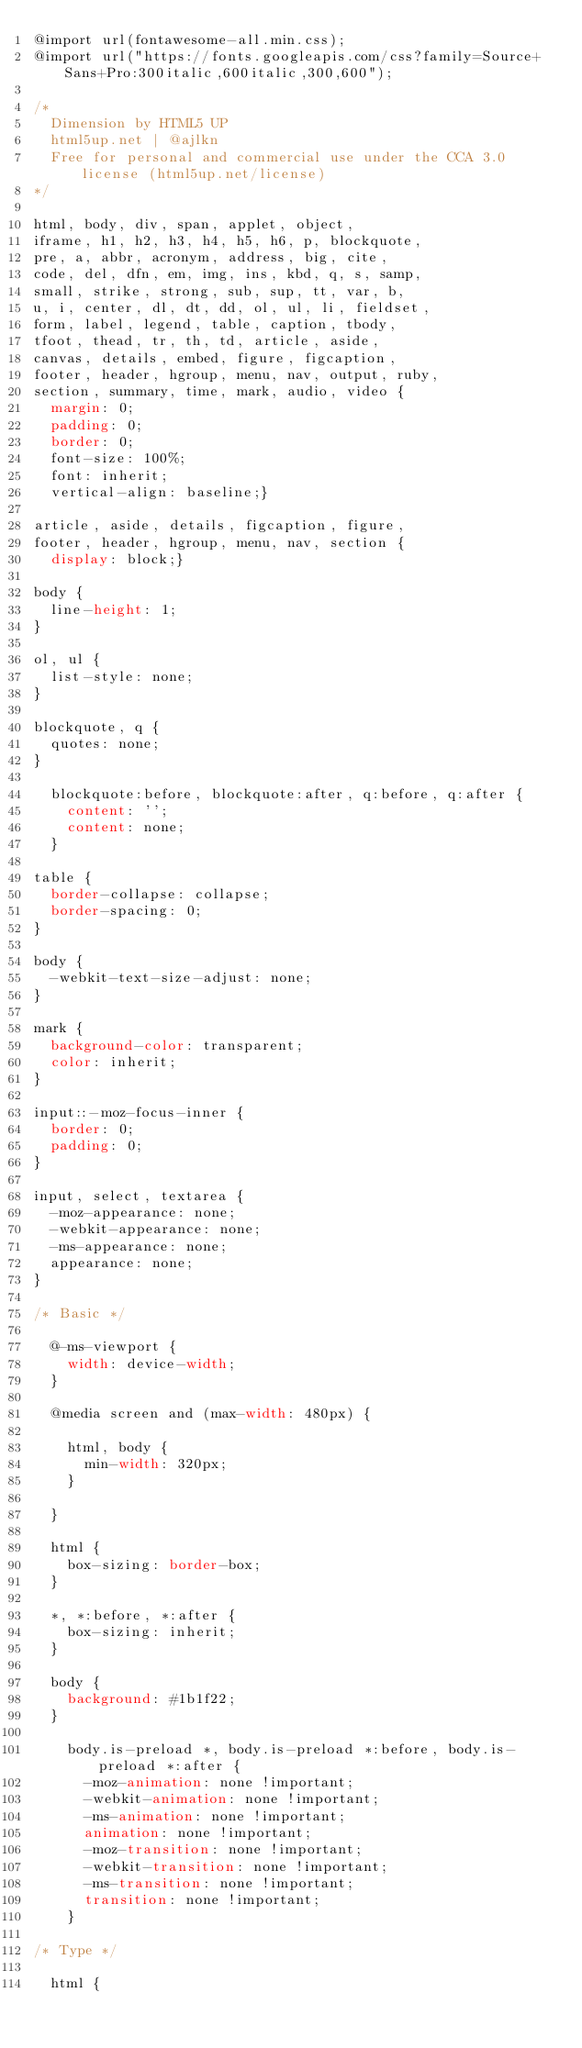Convert code to text. <code><loc_0><loc_0><loc_500><loc_500><_CSS_>@import url(fontawesome-all.min.css);
@import url("https://fonts.googleapis.com/css?family=Source+Sans+Pro:300italic,600italic,300,600");

/*
	Dimension by HTML5 UP
	html5up.net | @ajlkn
	Free for personal and commercial use under the CCA 3.0 license (html5up.net/license)
*/

html, body, div, span, applet, object,
iframe, h1, h2, h3, h4, h5, h6, p, blockquote,
pre, a, abbr, acronym, address, big, cite,
code, del, dfn, em, img, ins, kbd, q, s, samp,
small, strike, strong, sub, sup, tt, var, b,
u, i, center, dl, dt, dd, ol, ul, li, fieldset,
form, label, legend, table, caption, tbody,
tfoot, thead, tr, th, td, article, aside,
canvas, details, embed, figure, figcaption,
footer, header, hgroup, menu, nav, output, ruby,
section, summary, time, mark, audio, video {
	margin: 0;
	padding: 0;
	border: 0;
	font-size: 100%;
	font: inherit;
	vertical-align: baseline;}

article, aside, details, figcaption, figure,
footer, header, hgroup, menu, nav, section {
	display: block;}

body {
	line-height: 1;
}

ol, ul {
	list-style: none;
}

blockquote, q {
	quotes: none;
}

	blockquote:before, blockquote:after, q:before, q:after {
		content: '';
		content: none;
	}

table {
	border-collapse: collapse;
	border-spacing: 0;
}

body {
	-webkit-text-size-adjust: none;
}

mark {
	background-color: transparent;
	color: inherit;
}

input::-moz-focus-inner {
	border: 0;
	padding: 0;
}

input, select, textarea {
	-moz-appearance: none;
	-webkit-appearance: none;
	-ms-appearance: none;
	appearance: none;
}

/* Basic */

	@-ms-viewport {
		width: device-width;
	}

	@media screen and (max-width: 480px) {

		html, body {
			min-width: 320px;
		}

	}

	html {
		box-sizing: border-box;
	}

	*, *:before, *:after {
		box-sizing: inherit;
	}

	body {
		background: #1b1f22;
	}

		body.is-preload *, body.is-preload *:before, body.is-preload *:after {
			-moz-animation: none !important;
			-webkit-animation: none !important;
			-ms-animation: none !important;
			animation: none !important;
			-moz-transition: none !important;
			-webkit-transition: none !important;
			-ms-transition: none !important;
			transition: none !important;
		}

/* Type */

	html {</code> 